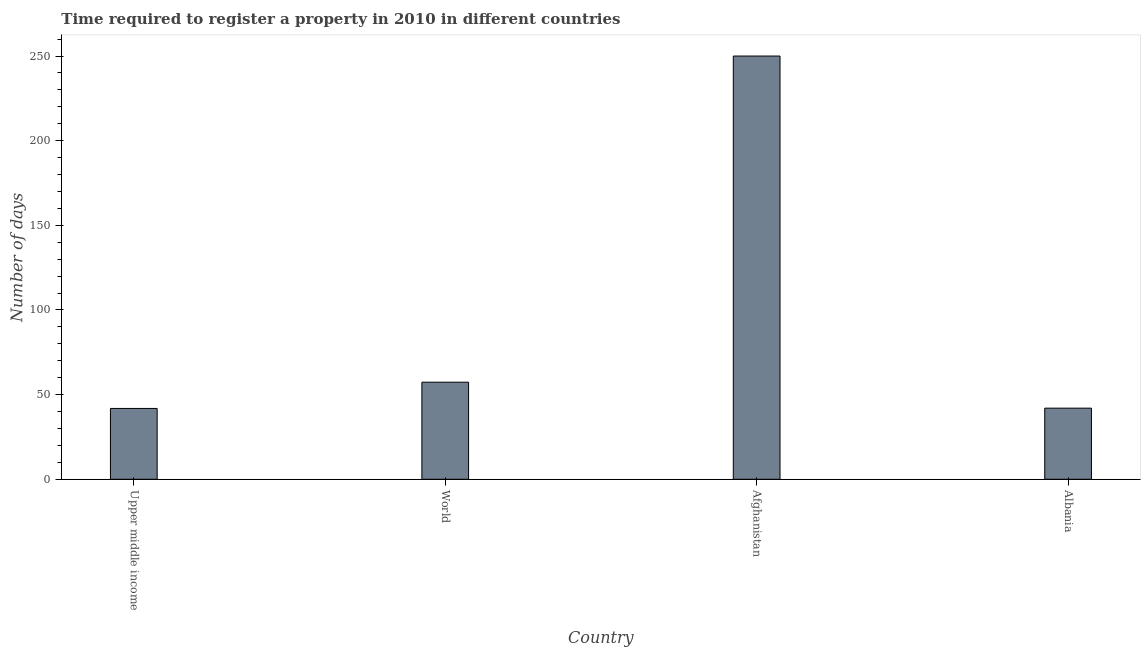Does the graph contain grids?
Give a very brief answer. No. What is the title of the graph?
Your answer should be compact. Time required to register a property in 2010 in different countries. What is the label or title of the X-axis?
Your response must be concise. Country. What is the label or title of the Y-axis?
Provide a succinct answer. Number of days. What is the number of days required to register property in Afghanistan?
Your answer should be compact. 250. Across all countries, what is the maximum number of days required to register property?
Your answer should be compact. 250. Across all countries, what is the minimum number of days required to register property?
Give a very brief answer. 41.84. In which country was the number of days required to register property maximum?
Your response must be concise. Afghanistan. In which country was the number of days required to register property minimum?
Give a very brief answer. Upper middle income. What is the sum of the number of days required to register property?
Ensure brevity in your answer.  391.18. What is the difference between the number of days required to register property in Afghanistan and Albania?
Offer a terse response. 208. What is the average number of days required to register property per country?
Give a very brief answer. 97.8. What is the median number of days required to register property?
Provide a succinct answer. 49.67. What is the ratio of the number of days required to register property in Upper middle income to that in World?
Offer a terse response. 0.73. What is the difference between the highest and the second highest number of days required to register property?
Ensure brevity in your answer.  192.66. What is the difference between the highest and the lowest number of days required to register property?
Give a very brief answer. 208.16. In how many countries, is the number of days required to register property greater than the average number of days required to register property taken over all countries?
Your answer should be compact. 1. How many bars are there?
Your answer should be compact. 4. What is the difference between two consecutive major ticks on the Y-axis?
Provide a short and direct response. 50. Are the values on the major ticks of Y-axis written in scientific E-notation?
Provide a short and direct response. No. What is the Number of days of Upper middle income?
Provide a short and direct response. 41.84. What is the Number of days in World?
Offer a terse response. 57.34. What is the Number of days in Afghanistan?
Your answer should be very brief. 250. What is the Number of days of Albania?
Offer a terse response. 42. What is the difference between the Number of days in Upper middle income and World?
Make the answer very short. -15.5. What is the difference between the Number of days in Upper middle income and Afghanistan?
Offer a terse response. -208.16. What is the difference between the Number of days in Upper middle income and Albania?
Provide a succinct answer. -0.16. What is the difference between the Number of days in World and Afghanistan?
Offer a terse response. -192.66. What is the difference between the Number of days in World and Albania?
Keep it short and to the point. 15.34. What is the difference between the Number of days in Afghanistan and Albania?
Ensure brevity in your answer.  208. What is the ratio of the Number of days in Upper middle income to that in World?
Make the answer very short. 0.73. What is the ratio of the Number of days in Upper middle income to that in Afghanistan?
Your response must be concise. 0.17. What is the ratio of the Number of days in Upper middle income to that in Albania?
Your answer should be compact. 1. What is the ratio of the Number of days in World to that in Afghanistan?
Give a very brief answer. 0.23. What is the ratio of the Number of days in World to that in Albania?
Your response must be concise. 1.36. What is the ratio of the Number of days in Afghanistan to that in Albania?
Your answer should be compact. 5.95. 